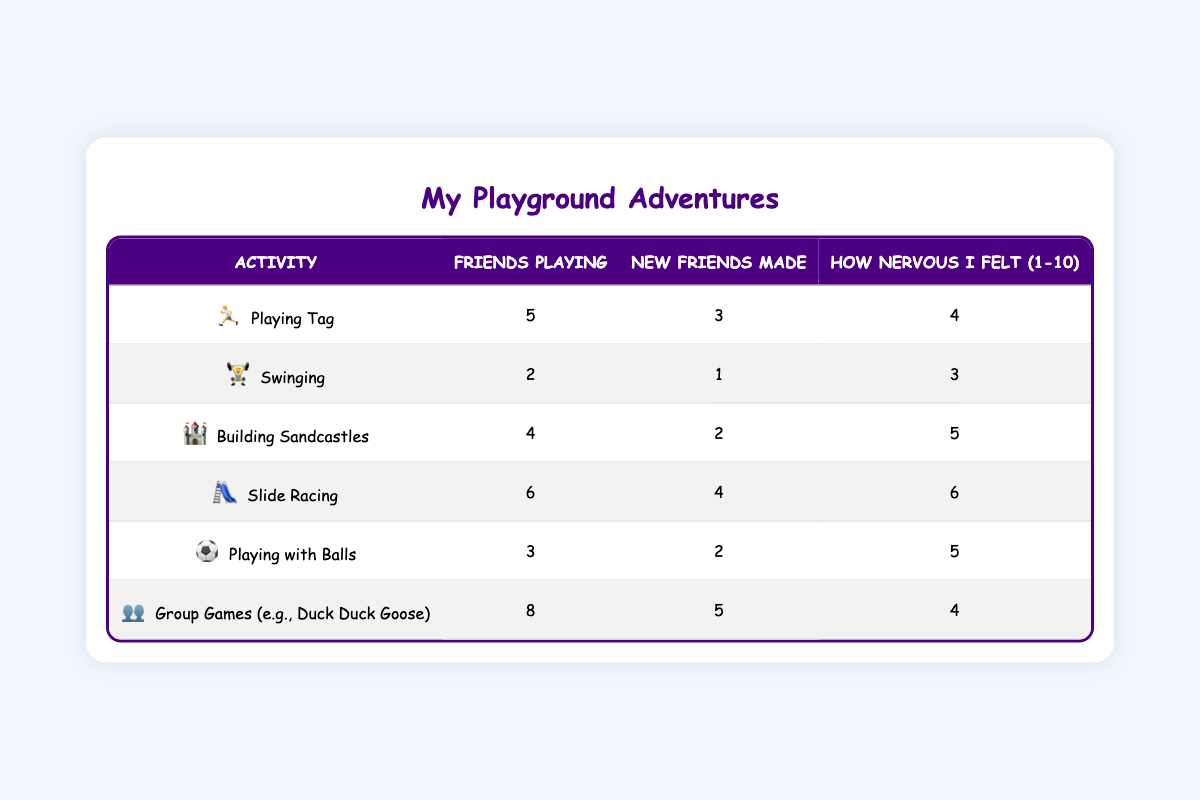What is the activity with the highest number of children involved? The activity with the highest number of children involved is "Group Games (e.g., Duck Duck Goose)" which has 8 children playing.
Answer: Group Games (e.g., Duck Duck Goose) How many friendships were formed while playing Tag? While playing Tag, 3 friendships were formed. This information is directly stated in the table under the "Friendships Formed" column for the Tag activity.
Answer: 3 What is the average anxiety level for all activities? To find the average anxiety level, sum the individual anxiety levels: 4 + 3 + 5 + 6 + 5 + 4 = 27. There are 6 activities, so the average is 27/6 = 4.5.
Answer: 4.5 Did more friendships form during Slide Racing compared to Swinging? For Slide Racing, 4 friendships were formed, and for Swinging, only 1 friendship was formed. Since 4 is greater than 1, yes, more friendships formed during Slide Racing than Swinging.
Answer: Yes What is the total number of children involved in all activities? To get the total number of children involved, add up the numbers from each activity: 5 + 2 + 4 + 6 + 3 + 8 = 28.
Answer: 28 Is the anxiety level for "Playing with Balls" higher than for "Building Sandcastles"? The anxiety level for Playing with Balls is 5, while for Building Sandcastles it is 5 too. Since they are equal, the answer is no; it is not higher.
Answer: No Which activity had the least number of friendships formed? The activity that had the least number of friendships formed is "Swinging," with only 1 friendship formed as indicated in the table.
Answer: Swinging If we compare "Building Sandcastles" and "Playing with Balls," which activity had less anxiety? The anxiety level for Building Sandcastles is 5, and for Playing with Balls, it is also 5. Since they are equal, neither had less anxiety; they are the same.
Answer: They are the same What is the total number of new friendships made across all activities? To find the total new friendships made, add up all the friendships formed: 3 + 1 + 2 + 4 + 2 + 5 = 17.
Answer: 17 